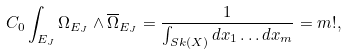<formula> <loc_0><loc_0><loc_500><loc_500>C _ { 0 } \int _ { E _ { J } } \Omega _ { E _ { J } } \wedge \overline { \Omega } _ { E _ { J } } = \frac { 1 } { \int _ { S k ( X ) } d x _ { 1 } \dots d x _ { m } } = m ! ,</formula> 